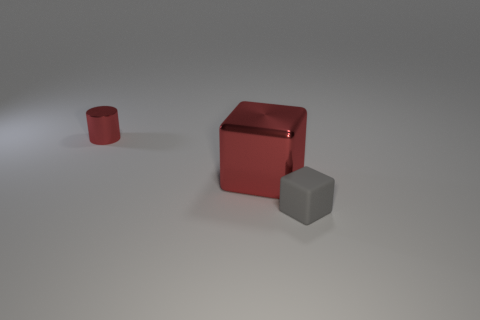Add 3 big metal cubes. How many objects exist? 6 Subtract all red blocks. How many blocks are left? 1 Subtract all blue blocks. How many gray cylinders are left? 0 Subtract all cylinders. How many objects are left? 2 Subtract 1 cylinders. How many cylinders are left? 0 Subtract all purple blocks. Subtract all gray cylinders. How many blocks are left? 2 Subtract all shiny cylinders. Subtract all small red metallic cylinders. How many objects are left? 1 Add 3 shiny cylinders. How many shiny cylinders are left? 4 Add 3 red metal objects. How many red metal objects exist? 5 Subtract 0 gray spheres. How many objects are left? 3 